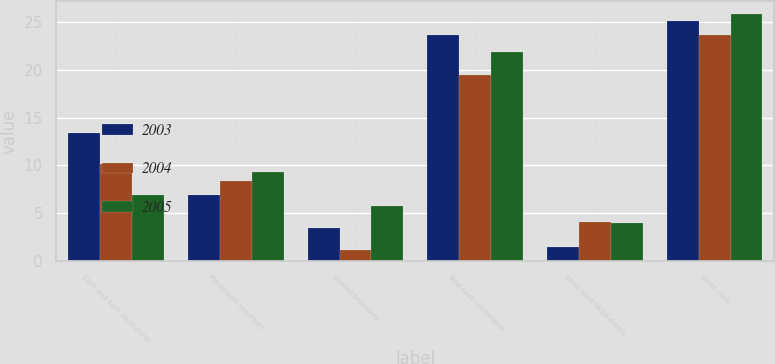<chart> <loc_0><loc_0><loc_500><loc_500><stacked_bar_chart><ecel><fcel>Cash and cash equivalents<fcel>Marketable securities<fcel>Loaned securities<fcel>Total cash marketable<fcel>Short-term VEBA assets<fcel>Gross cash<nl><fcel>2003<fcel>13.4<fcel>6.9<fcel>3.4<fcel>23.7<fcel>1.4<fcel>25.1<nl><fcel>2004<fcel>10.1<fcel>8.3<fcel>1.1<fcel>19.5<fcel>4.1<fcel>23.6<nl><fcel>2005<fcel>6.9<fcel>9.3<fcel>5.7<fcel>21.9<fcel>4<fcel>25.9<nl></chart> 